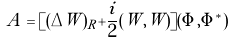Convert formula to latex. <formula><loc_0><loc_0><loc_500><loc_500>A = [ ( \Delta W ) _ { R } + \frac { i } { 2 } ( W , W ) ] ( \Phi , \Phi ^ { * } )</formula> 